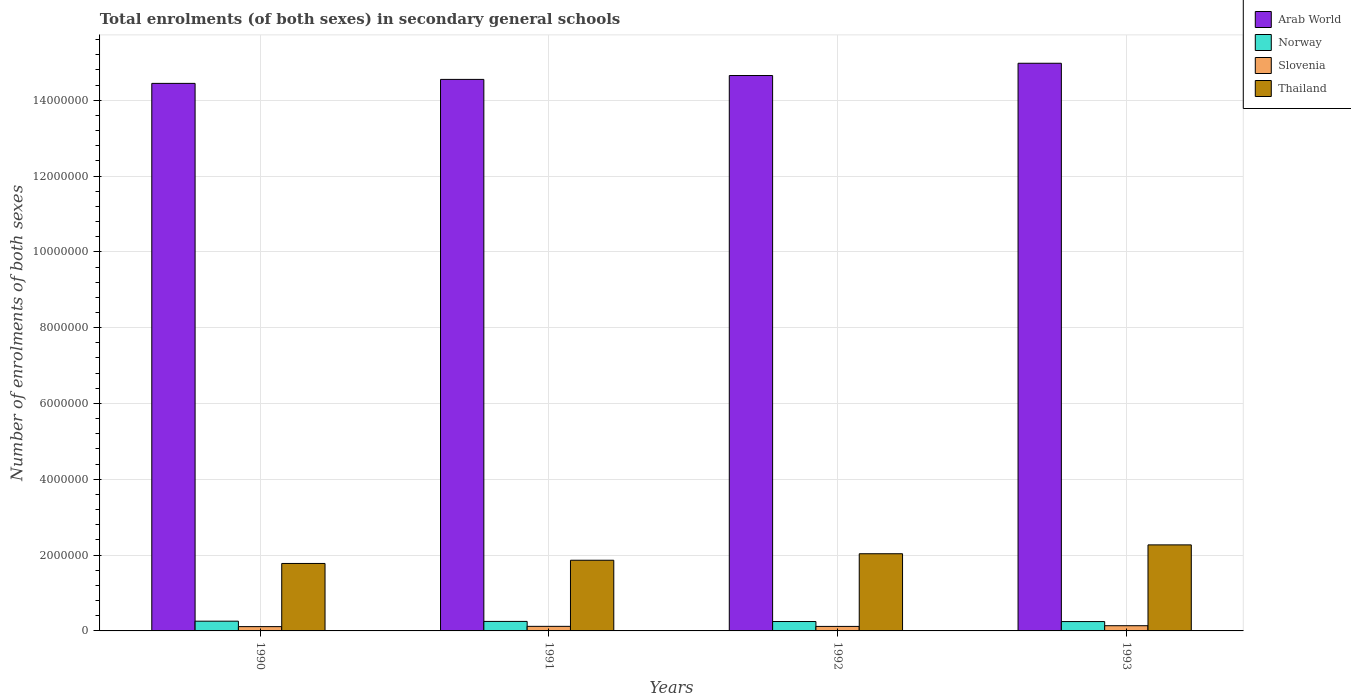Are the number of bars per tick equal to the number of legend labels?
Make the answer very short. Yes. Are the number of bars on each tick of the X-axis equal?
Your answer should be compact. Yes. How many bars are there on the 3rd tick from the left?
Your answer should be compact. 4. How many bars are there on the 4th tick from the right?
Offer a very short reply. 4. What is the label of the 2nd group of bars from the left?
Make the answer very short. 1991. In how many cases, is the number of bars for a given year not equal to the number of legend labels?
Give a very brief answer. 0. What is the number of enrolments in secondary schools in Slovenia in 1993?
Provide a short and direct response. 1.37e+05. Across all years, what is the maximum number of enrolments in secondary schools in Slovenia?
Provide a succinct answer. 1.37e+05. Across all years, what is the minimum number of enrolments in secondary schools in Arab World?
Ensure brevity in your answer.  1.44e+07. In which year was the number of enrolments in secondary schools in Norway maximum?
Ensure brevity in your answer.  1990. What is the total number of enrolments in secondary schools in Norway in the graph?
Give a very brief answer. 1.00e+06. What is the difference between the number of enrolments in secondary schools in Slovenia in 1990 and that in 1993?
Give a very brief answer. -2.39e+04. What is the difference between the number of enrolments in secondary schools in Thailand in 1991 and the number of enrolments in secondary schools in Norway in 1990?
Make the answer very short. 1.61e+06. What is the average number of enrolments in secondary schools in Norway per year?
Offer a very short reply. 2.51e+05. In the year 1991, what is the difference between the number of enrolments in secondary schools in Arab World and number of enrolments in secondary schools in Slovenia?
Your response must be concise. 1.44e+07. What is the ratio of the number of enrolments in secondary schools in Arab World in 1990 to that in 1993?
Offer a terse response. 0.96. Is the number of enrolments in secondary schools in Thailand in 1990 less than that in 1992?
Your response must be concise. Yes. What is the difference between the highest and the second highest number of enrolments in secondary schools in Arab World?
Give a very brief answer. 3.23e+05. What is the difference between the highest and the lowest number of enrolments in secondary schools in Norway?
Your response must be concise. 1.05e+04. Is the sum of the number of enrolments in secondary schools in Arab World in 1991 and 1992 greater than the maximum number of enrolments in secondary schools in Slovenia across all years?
Your response must be concise. Yes. Is it the case that in every year, the sum of the number of enrolments in secondary schools in Arab World and number of enrolments in secondary schools in Norway is greater than the sum of number of enrolments in secondary schools in Thailand and number of enrolments in secondary schools in Slovenia?
Offer a terse response. Yes. What does the 1st bar from the left in 1992 represents?
Offer a terse response. Arab World. What does the 4th bar from the right in 1992 represents?
Ensure brevity in your answer.  Arab World. Is it the case that in every year, the sum of the number of enrolments in secondary schools in Norway and number of enrolments in secondary schools in Slovenia is greater than the number of enrolments in secondary schools in Thailand?
Your answer should be compact. No. How many bars are there?
Your answer should be very brief. 16. Are all the bars in the graph horizontal?
Offer a very short reply. No. What is the difference between two consecutive major ticks on the Y-axis?
Give a very brief answer. 2.00e+06. Does the graph contain any zero values?
Your response must be concise. No. Where does the legend appear in the graph?
Provide a succinct answer. Top right. How are the legend labels stacked?
Offer a very short reply. Vertical. What is the title of the graph?
Offer a terse response. Total enrolments (of both sexes) in secondary general schools. What is the label or title of the Y-axis?
Make the answer very short. Number of enrolments of both sexes. What is the Number of enrolments of both sexes of Arab World in 1990?
Make the answer very short. 1.44e+07. What is the Number of enrolments of both sexes of Norway in 1990?
Keep it short and to the point. 2.57e+05. What is the Number of enrolments of both sexes in Slovenia in 1990?
Offer a very short reply. 1.14e+05. What is the Number of enrolments of both sexes in Thailand in 1990?
Give a very brief answer. 1.78e+06. What is the Number of enrolments of both sexes in Arab World in 1991?
Ensure brevity in your answer.  1.45e+07. What is the Number of enrolments of both sexes of Norway in 1991?
Keep it short and to the point. 2.51e+05. What is the Number of enrolments of both sexes in Slovenia in 1991?
Provide a short and direct response. 1.20e+05. What is the Number of enrolments of both sexes in Thailand in 1991?
Provide a succinct answer. 1.86e+06. What is the Number of enrolments of both sexes of Arab World in 1992?
Your response must be concise. 1.47e+07. What is the Number of enrolments of both sexes of Norway in 1992?
Give a very brief answer. 2.48e+05. What is the Number of enrolments of both sexes in Slovenia in 1992?
Your response must be concise. 1.19e+05. What is the Number of enrolments of both sexes of Thailand in 1992?
Offer a terse response. 2.04e+06. What is the Number of enrolments of both sexes of Arab World in 1993?
Ensure brevity in your answer.  1.50e+07. What is the Number of enrolments of both sexes of Norway in 1993?
Offer a very short reply. 2.47e+05. What is the Number of enrolments of both sexes of Slovenia in 1993?
Provide a short and direct response. 1.37e+05. What is the Number of enrolments of both sexes in Thailand in 1993?
Your response must be concise. 2.27e+06. Across all years, what is the maximum Number of enrolments of both sexes in Arab World?
Offer a terse response. 1.50e+07. Across all years, what is the maximum Number of enrolments of both sexes of Norway?
Give a very brief answer. 2.57e+05. Across all years, what is the maximum Number of enrolments of both sexes of Slovenia?
Provide a short and direct response. 1.37e+05. Across all years, what is the maximum Number of enrolments of both sexes in Thailand?
Your answer should be compact. 2.27e+06. Across all years, what is the minimum Number of enrolments of both sexes in Arab World?
Provide a short and direct response. 1.44e+07. Across all years, what is the minimum Number of enrolments of both sexes of Norway?
Offer a very short reply. 2.47e+05. Across all years, what is the minimum Number of enrolments of both sexes of Slovenia?
Keep it short and to the point. 1.14e+05. Across all years, what is the minimum Number of enrolments of both sexes of Thailand?
Offer a terse response. 1.78e+06. What is the total Number of enrolments of both sexes in Arab World in the graph?
Give a very brief answer. 5.86e+07. What is the total Number of enrolments of both sexes in Norway in the graph?
Provide a succinct answer. 1.00e+06. What is the total Number of enrolments of both sexes of Slovenia in the graph?
Make the answer very short. 4.90e+05. What is the total Number of enrolments of both sexes in Thailand in the graph?
Your response must be concise. 7.95e+06. What is the difference between the Number of enrolments of both sexes in Arab World in 1990 and that in 1991?
Offer a very short reply. -1.05e+05. What is the difference between the Number of enrolments of both sexes in Norway in 1990 and that in 1991?
Provide a succinct answer. 6452. What is the difference between the Number of enrolments of both sexes of Slovenia in 1990 and that in 1991?
Offer a very short reply. -6898. What is the difference between the Number of enrolments of both sexes in Thailand in 1990 and that in 1991?
Ensure brevity in your answer.  -8.48e+04. What is the difference between the Number of enrolments of both sexes of Arab World in 1990 and that in 1992?
Offer a very short reply. -2.08e+05. What is the difference between the Number of enrolments of both sexes of Norway in 1990 and that in 1992?
Offer a very short reply. 9113. What is the difference between the Number of enrolments of both sexes in Slovenia in 1990 and that in 1992?
Provide a short and direct response. -5394. What is the difference between the Number of enrolments of both sexes of Thailand in 1990 and that in 1992?
Your answer should be very brief. -2.56e+05. What is the difference between the Number of enrolments of both sexes of Arab World in 1990 and that in 1993?
Give a very brief answer. -5.31e+05. What is the difference between the Number of enrolments of both sexes in Norway in 1990 and that in 1993?
Provide a succinct answer. 1.05e+04. What is the difference between the Number of enrolments of both sexes in Slovenia in 1990 and that in 1993?
Make the answer very short. -2.39e+04. What is the difference between the Number of enrolments of both sexes in Thailand in 1990 and that in 1993?
Provide a short and direct response. -4.90e+05. What is the difference between the Number of enrolments of both sexes of Arab World in 1991 and that in 1992?
Offer a very short reply. -1.03e+05. What is the difference between the Number of enrolments of both sexes of Norway in 1991 and that in 1992?
Provide a succinct answer. 2661. What is the difference between the Number of enrolments of both sexes of Slovenia in 1991 and that in 1992?
Make the answer very short. 1504. What is the difference between the Number of enrolments of both sexes of Thailand in 1991 and that in 1992?
Your answer should be compact. -1.72e+05. What is the difference between the Number of enrolments of both sexes of Arab World in 1991 and that in 1993?
Ensure brevity in your answer.  -4.26e+05. What is the difference between the Number of enrolments of both sexes of Norway in 1991 and that in 1993?
Provide a succinct answer. 4049. What is the difference between the Number of enrolments of both sexes of Slovenia in 1991 and that in 1993?
Your response must be concise. -1.70e+04. What is the difference between the Number of enrolments of both sexes in Thailand in 1991 and that in 1993?
Give a very brief answer. -4.05e+05. What is the difference between the Number of enrolments of both sexes in Arab World in 1992 and that in 1993?
Ensure brevity in your answer.  -3.23e+05. What is the difference between the Number of enrolments of both sexes in Norway in 1992 and that in 1993?
Provide a short and direct response. 1388. What is the difference between the Number of enrolments of both sexes of Slovenia in 1992 and that in 1993?
Ensure brevity in your answer.  -1.85e+04. What is the difference between the Number of enrolments of both sexes in Thailand in 1992 and that in 1993?
Ensure brevity in your answer.  -2.33e+05. What is the difference between the Number of enrolments of both sexes of Arab World in 1990 and the Number of enrolments of both sexes of Norway in 1991?
Your answer should be very brief. 1.42e+07. What is the difference between the Number of enrolments of both sexes of Arab World in 1990 and the Number of enrolments of both sexes of Slovenia in 1991?
Your answer should be compact. 1.43e+07. What is the difference between the Number of enrolments of both sexes in Arab World in 1990 and the Number of enrolments of both sexes in Thailand in 1991?
Give a very brief answer. 1.26e+07. What is the difference between the Number of enrolments of both sexes in Norway in 1990 and the Number of enrolments of both sexes in Slovenia in 1991?
Your answer should be compact. 1.37e+05. What is the difference between the Number of enrolments of both sexes in Norway in 1990 and the Number of enrolments of both sexes in Thailand in 1991?
Give a very brief answer. -1.61e+06. What is the difference between the Number of enrolments of both sexes of Slovenia in 1990 and the Number of enrolments of both sexes of Thailand in 1991?
Provide a succinct answer. -1.75e+06. What is the difference between the Number of enrolments of both sexes in Arab World in 1990 and the Number of enrolments of both sexes in Norway in 1992?
Keep it short and to the point. 1.42e+07. What is the difference between the Number of enrolments of both sexes in Arab World in 1990 and the Number of enrolments of both sexes in Slovenia in 1992?
Make the answer very short. 1.43e+07. What is the difference between the Number of enrolments of both sexes of Arab World in 1990 and the Number of enrolments of both sexes of Thailand in 1992?
Offer a very short reply. 1.24e+07. What is the difference between the Number of enrolments of both sexes of Norway in 1990 and the Number of enrolments of both sexes of Slovenia in 1992?
Keep it short and to the point. 1.38e+05. What is the difference between the Number of enrolments of both sexes in Norway in 1990 and the Number of enrolments of both sexes in Thailand in 1992?
Provide a succinct answer. -1.78e+06. What is the difference between the Number of enrolments of both sexes of Slovenia in 1990 and the Number of enrolments of both sexes of Thailand in 1992?
Ensure brevity in your answer.  -1.92e+06. What is the difference between the Number of enrolments of both sexes in Arab World in 1990 and the Number of enrolments of both sexes in Norway in 1993?
Offer a very short reply. 1.42e+07. What is the difference between the Number of enrolments of both sexes in Arab World in 1990 and the Number of enrolments of both sexes in Slovenia in 1993?
Offer a terse response. 1.43e+07. What is the difference between the Number of enrolments of both sexes of Arab World in 1990 and the Number of enrolments of both sexes of Thailand in 1993?
Keep it short and to the point. 1.22e+07. What is the difference between the Number of enrolments of both sexes in Norway in 1990 and the Number of enrolments of both sexes in Slovenia in 1993?
Keep it short and to the point. 1.20e+05. What is the difference between the Number of enrolments of both sexes of Norway in 1990 and the Number of enrolments of both sexes of Thailand in 1993?
Your answer should be very brief. -2.01e+06. What is the difference between the Number of enrolments of both sexes in Slovenia in 1990 and the Number of enrolments of both sexes in Thailand in 1993?
Make the answer very short. -2.16e+06. What is the difference between the Number of enrolments of both sexes of Arab World in 1991 and the Number of enrolments of both sexes of Norway in 1992?
Your answer should be compact. 1.43e+07. What is the difference between the Number of enrolments of both sexes in Arab World in 1991 and the Number of enrolments of both sexes in Slovenia in 1992?
Keep it short and to the point. 1.44e+07. What is the difference between the Number of enrolments of both sexes of Arab World in 1991 and the Number of enrolments of both sexes of Thailand in 1992?
Ensure brevity in your answer.  1.25e+07. What is the difference between the Number of enrolments of both sexes of Norway in 1991 and the Number of enrolments of both sexes of Slovenia in 1992?
Provide a short and direct response. 1.32e+05. What is the difference between the Number of enrolments of both sexes of Norway in 1991 and the Number of enrolments of both sexes of Thailand in 1992?
Your answer should be compact. -1.79e+06. What is the difference between the Number of enrolments of both sexes in Slovenia in 1991 and the Number of enrolments of both sexes in Thailand in 1992?
Your response must be concise. -1.92e+06. What is the difference between the Number of enrolments of both sexes in Arab World in 1991 and the Number of enrolments of both sexes in Norway in 1993?
Ensure brevity in your answer.  1.43e+07. What is the difference between the Number of enrolments of both sexes in Arab World in 1991 and the Number of enrolments of both sexes in Slovenia in 1993?
Offer a very short reply. 1.44e+07. What is the difference between the Number of enrolments of both sexes of Arab World in 1991 and the Number of enrolments of both sexes of Thailand in 1993?
Ensure brevity in your answer.  1.23e+07. What is the difference between the Number of enrolments of both sexes in Norway in 1991 and the Number of enrolments of both sexes in Slovenia in 1993?
Provide a short and direct response. 1.13e+05. What is the difference between the Number of enrolments of both sexes in Norway in 1991 and the Number of enrolments of both sexes in Thailand in 1993?
Offer a very short reply. -2.02e+06. What is the difference between the Number of enrolments of both sexes of Slovenia in 1991 and the Number of enrolments of both sexes of Thailand in 1993?
Your response must be concise. -2.15e+06. What is the difference between the Number of enrolments of both sexes in Arab World in 1992 and the Number of enrolments of both sexes in Norway in 1993?
Offer a very short reply. 1.44e+07. What is the difference between the Number of enrolments of both sexes of Arab World in 1992 and the Number of enrolments of both sexes of Slovenia in 1993?
Ensure brevity in your answer.  1.45e+07. What is the difference between the Number of enrolments of both sexes of Arab World in 1992 and the Number of enrolments of both sexes of Thailand in 1993?
Offer a very short reply. 1.24e+07. What is the difference between the Number of enrolments of both sexes of Norway in 1992 and the Number of enrolments of both sexes of Slovenia in 1993?
Make the answer very short. 1.11e+05. What is the difference between the Number of enrolments of both sexes of Norway in 1992 and the Number of enrolments of both sexes of Thailand in 1993?
Offer a terse response. -2.02e+06. What is the difference between the Number of enrolments of both sexes in Slovenia in 1992 and the Number of enrolments of both sexes in Thailand in 1993?
Offer a very short reply. -2.15e+06. What is the average Number of enrolments of both sexes of Arab World per year?
Your answer should be very brief. 1.47e+07. What is the average Number of enrolments of both sexes of Norway per year?
Provide a short and direct response. 2.51e+05. What is the average Number of enrolments of both sexes of Slovenia per year?
Provide a succinct answer. 1.23e+05. What is the average Number of enrolments of both sexes of Thailand per year?
Provide a succinct answer. 1.99e+06. In the year 1990, what is the difference between the Number of enrolments of both sexes in Arab World and Number of enrolments of both sexes in Norway?
Provide a short and direct response. 1.42e+07. In the year 1990, what is the difference between the Number of enrolments of both sexes of Arab World and Number of enrolments of both sexes of Slovenia?
Your response must be concise. 1.43e+07. In the year 1990, what is the difference between the Number of enrolments of both sexes in Arab World and Number of enrolments of both sexes in Thailand?
Make the answer very short. 1.27e+07. In the year 1990, what is the difference between the Number of enrolments of both sexes in Norway and Number of enrolments of both sexes in Slovenia?
Ensure brevity in your answer.  1.44e+05. In the year 1990, what is the difference between the Number of enrolments of both sexes in Norway and Number of enrolments of both sexes in Thailand?
Make the answer very short. -1.52e+06. In the year 1990, what is the difference between the Number of enrolments of both sexes in Slovenia and Number of enrolments of both sexes in Thailand?
Your answer should be very brief. -1.67e+06. In the year 1991, what is the difference between the Number of enrolments of both sexes of Arab World and Number of enrolments of both sexes of Norway?
Keep it short and to the point. 1.43e+07. In the year 1991, what is the difference between the Number of enrolments of both sexes of Arab World and Number of enrolments of both sexes of Slovenia?
Keep it short and to the point. 1.44e+07. In the year 1991, what is the difference between the Number of enrolments of both sexes of Arab World and Number of enrolments of both sexes of Thailand?
Your response must be concise. 1.27e+07. In the year 1991, what is the difference between the Number of enrolments of both sexes in Norway and Number of enrolments of both sexes in Slovenia?
Your answer should be very brief. 1.30e+05. In the year 1991, what is the difference between the Number of enrolments of both sexes in Norway and Number of enrolments of both sexes in Thailand?
Ensure brevity in your answer.  -1.61e+06. In the year 1991, what is the difference between the Number of enrolments of both sexes in Slovenia and Number of enrolments of both sexes in Thailand?
Provide a short and direct response. -1.74e+06. In the year 1992, what is the difference between the Number of enrolments of both sexes in Arab World and Number of enrolments of both sexes in Norway?
Ensure brevity in your answer.  1.44e+07. In the year 1992, what is the difference between the Number of enrolments of both sexes of Arab World and Number of enrolments of both sexes of Slovenia?
Offer a very short reply. 1.45e+07. In the year 1992, what is the difference between the Number of enrolments of both sexes in Arab World and Number of enrolments of both sexes in Thailand?
Your answer should be compact. 1.26e+07. In the year 1992, what is the difference between the Number of enrolments of both sexes in Norway and Number of enrolments of both sexes in Slovenia?
Provide a short and direct response. 1.29e+05. In the year 1992, what is the difference between the Number of enrolments of both sexes of Norway and Number of enrolments of both sexes of Thailand?
Offer a very short reply. -1.79e+06. In the year 1992, what is the difference between the Number of enrolments of both sexes in Slovenia and Number of enrolments of both sexes in Thailand?
Provide a short and direct response. -1.92e+06. In the year 1993, what is the difference between the Number of enrolments of both sexes of Arab World and Number of enrolments of both sexes of Norway?
Offer a terse response. 1.47e+07. In the year 1993, what is the difference between the Number of enrolments of both sexes of Arab World and Number of enrolments of both sexes of Slovenia?
Ensure brevity in your answer.  1.48e+07. In the year 1993, what is the difference between the Number of enrolments of both sexes of Arab World and Number of enrolments of both sexes of Thailand?
Your response must be concise. 1.27e+07. In the year 1993, what is the difference between the Number of enrolments of both sexes in Norway and Number of enrolments of both sexes in Slovenia?
Provide a short and direct response. 1.09e+05. In the year 1993, what is the difference between the Number of enrolments of both sexes of Norway and Number of enrolments of both sexes of Thailand?
Provide a succinct answer. -2.02e+06. In the year 1993, what is the difference between the Number of enrolments of both sexes in Slovenia and Number of enrolments of both sexes in Thailand?
Your response must be concise. -2.13e+06. What is the ratio of the Number of enrolments of both sexes in Norway in 1990 to that in 1991?
Give a very brief answer. 1.03. What is the ratio of the Number of enrolments of both sexes in Slovenia in 1990 to that in 1991?
Offer a very short reply. 0.94. What is the ratio of the Number of enrolments of both sexes of Thailand in 1990 to that in 1991?
Make the answer very short. 0.95. What is the ratio of the Number of enrolments of both sexes in Arab World in 1990 to that in 1992?
Give a very brief answer. 0.99. What is the ratio of the Number of enrolments of both sexes in Norway in 1990 to that in 1992?
Your answer should be very brief. 1.04. What is the ratio of the Number of enrolments of both sexes of Slovenia in 1990 to that in 1992?
Make the answer very short. 0.95. What is the ratio of the Number of enrolments of both sexes of Thailand in 1990 to that in 1992?
Keep it short and to the point. 0.87. What is the ratio of the Number of enrolments of both sexes of Arab World in 1990 to that in 1993?
Give a very brief answer. 0.96. What is the ratio of the Number of enrolments of both sexes in Norway in 1990 to that in 1993?
Your response must be concise. 1.04. What is the ratio of the Number of enrolments of both sexes of Slovenia in 1990 to that in 1993?
Make the answer very short. 0.83. What is the ratio of the Number of enrolments of both sexes of Thailand in 1990 to that in 1993?
Give a very brief answer. 0.78. What is the ratio of the Number of enrolments of both sexes in Norway in 1991 to that in 1992?
Your answer should be very brief. 1.01. What is the ratio of the Number of enrolments of both sexes in Slovenia in 1991 to that in 1992?
Offer a terse response. 1.01. What is the ratio of the Number of enrolments of both sexes of Thailand in 1991 to that in 1992?
Offer a terse response. 0.92. What is the ratio of the Number of enrolments of both sexes of Arab World in 1991 to that in 1993?
Keep it short and to the point. 0.97. What is the ratio of the Number of enrolments of both sexes of Norway in 1991 to that in 1993?
Ensure brevity in your answer.  1.02. What is the ratio of the Number of enrolments of both sexes in Slovenia in 1991 to that in 1993?
Provide a short and direct response. 0.88. What is the ratio of the Number of enrolments of both sexes of Thailand in 1991 to that in 1993?
Provide a succinct answer. 0.82. What is the ratio of the Number of enrolments of both sexes in Arab World in 1992 to that in 1993?
Offer a terse response. 0.98. What is the ratio of the Number of enrolments of both sexes of Norway in 1992 to that in 1993?
Ensure brevity in your answer.  1.01. What is the ratio of the Number of enrolments of both sexes of Slovenia in 1992 to that in 1993?
Make the answer very short. 0.87. What is the ratio of the Number of enrolments of both sexes of Thailand in 1992 to that in 1993?
Your answer should be compact. 0.9. What is the difference between the highest and the second highest Number of enrolments of both sexes of Arab World?
Offer a very short reply. 3.23e+05. What is the difference between the highest and the second highest Number of enrolments of both sexes of Norway?
Your response must be concise. 6452. What is the difference between the highest and the second highest Number of enrolments of both sexes of Slovenia?
Ensure brevity in your answer.  1.70e+04. What is the difference between the highest and the second highest Number of enrolments of both sexes of Thailand?
Your response must be concise. 2.33e+05. What is the difference between the highest and the lowest Number of enrolments of both sexes in Arab World?
Offer a terse response. 5.31e+05. What is the difference between the highest and the lowest Number of enrolments of both sexes in Norway?
Offer a terse response. 1.05e+04. What is the difference between the highest and the lowest Number of enrolments of both sexes in Slovenia?
Ensure brevity in your answer.  2.39e+04. What is the difference between the highest and the lowest Number of enrolments of both sexes in Thailand?
Make the answer very short. 4.90e+05. 